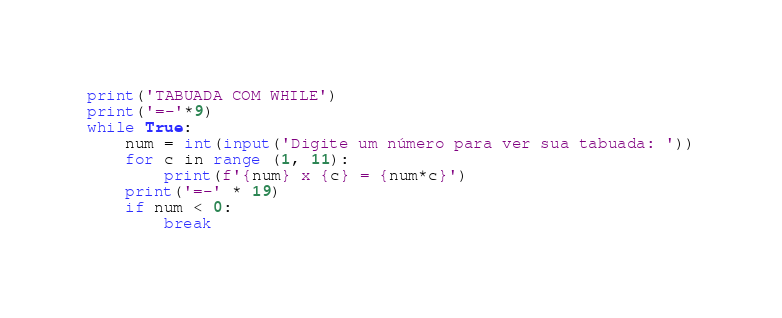Convert code to text. <code><loc_0><loc_0><loc_500><loc_500><_Python_>print('TABUADA COM WHILE')
print('=-'*9)
while True:
    num = int(input('Digite um número para ver sua tabuada: '))
    for c in range (1, 11):
        print(f'{num} x {c} = {num*c}')
    print('=-' * 19)
    if num < 0:
        break</code> 